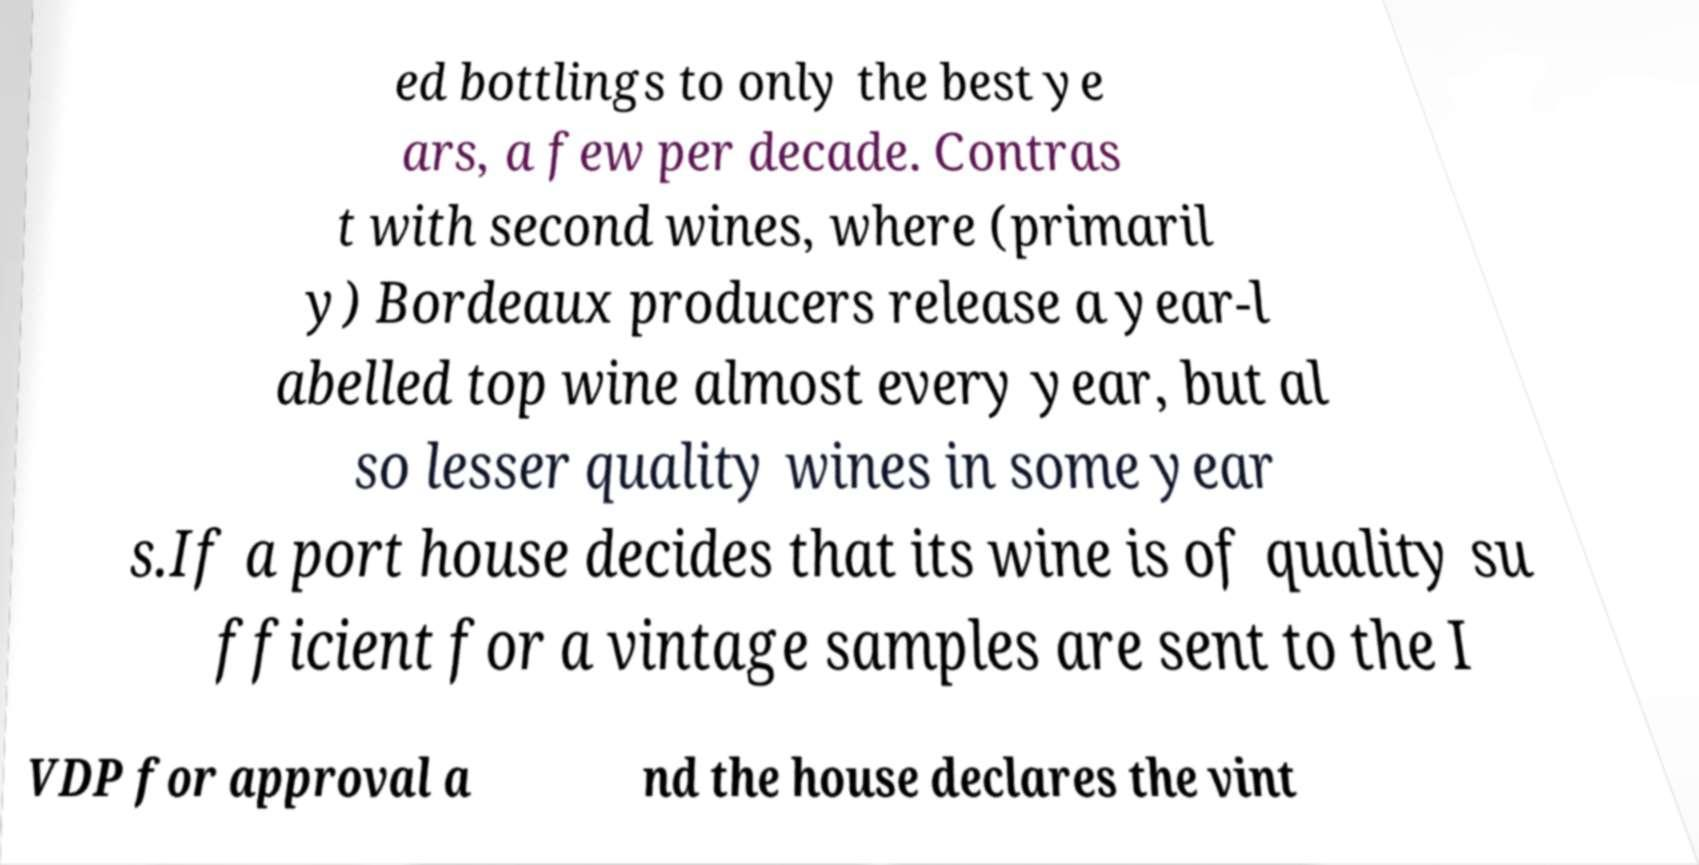Can you read and provide the text displayed in the image?This photo seems to have some interesting text. Can you extract and type it out for me? ed bottlings to only the best ye ars, a few per decade. Contras t with second wines, where (primaril y) Bordeaux producers release a year-l abelled top wine almost every year, but al so lesser quality wines in some year s.If a port house decides that its wine is of quality su fficient for a vintage samples are sent to the I VDP for approval a nd the house declares the vint 